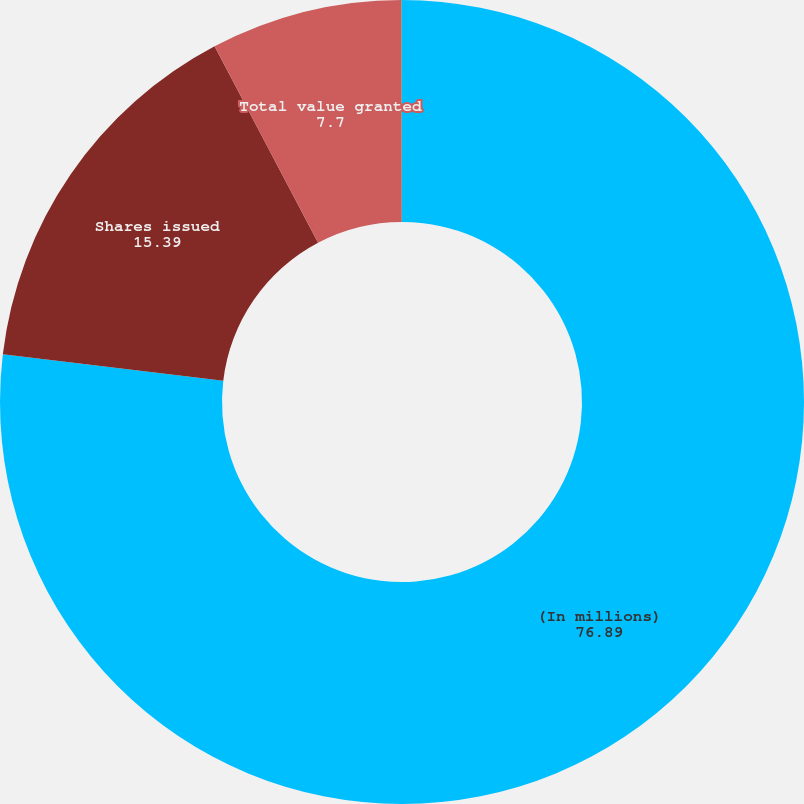<chart> <loc_0><loc_0><loc_500><loc_500><pie_chart><fcel>(In millions)<fcel>Shares issued<fcel>Total value granted<fcel>Compensation expense<nl><fcel>76.89%<fcel>15.39%<fcel>7.7%<fcel>0.02%<nl></chart> 